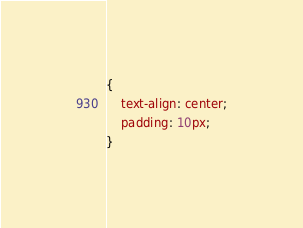<code> <loc_0><loc_0><loc_500><loc_500><_CSS_>{
    text-align: center;
    padding: 10px;
}


</code> 